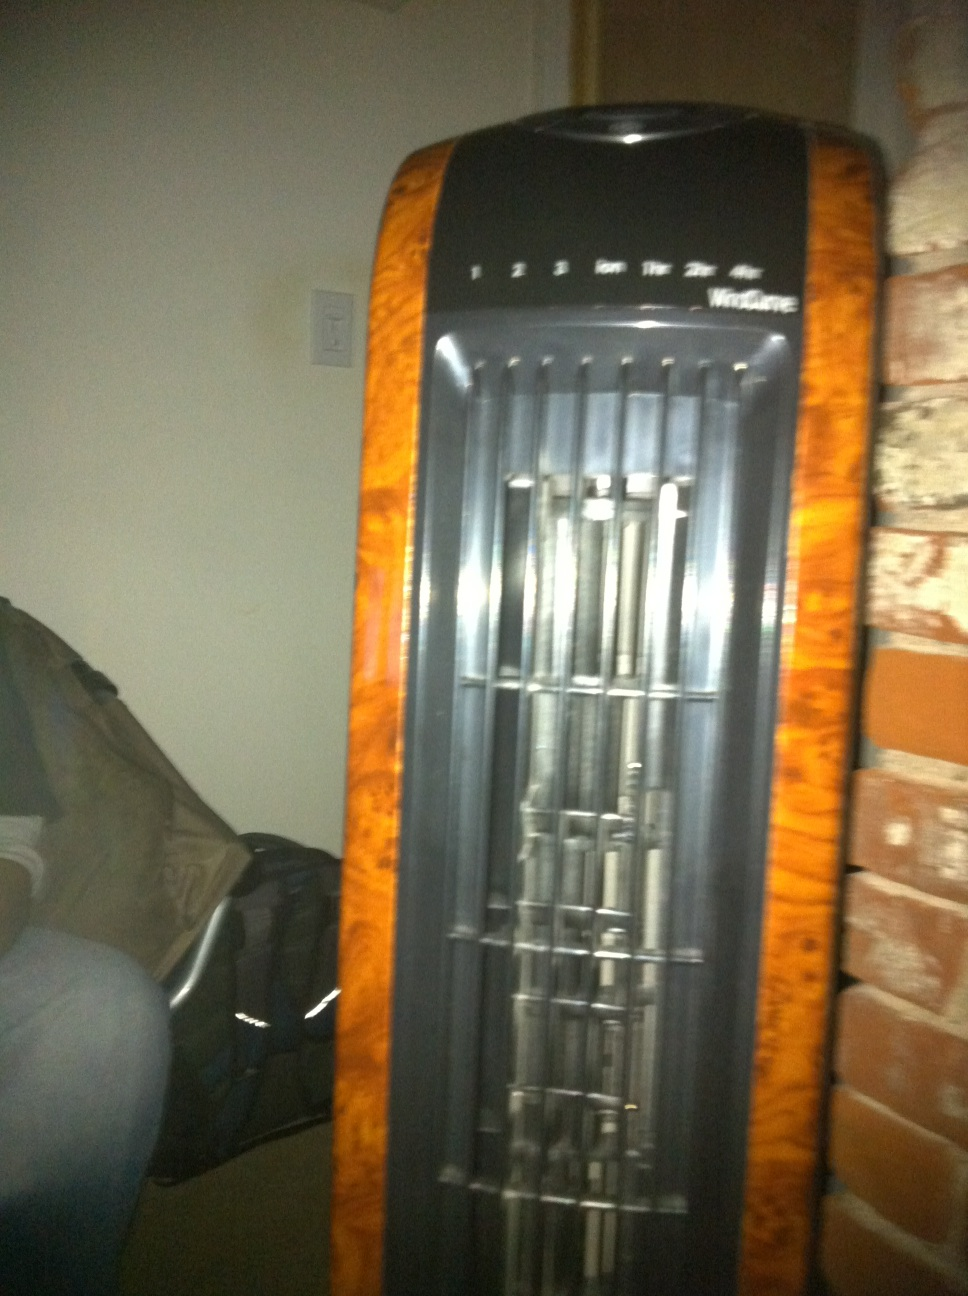What are the pros and cons of using this type of fan? Pros:
1. Space-efficient design, ideal for small areas.
2. Multiple speed settings for customizable airflow.
3. Quiet operation, suitable for use during sleep or work.
4. Modern and sleek appearance that can blend well with home decor.

Cons:
1. May not be as powerful as larger fans or air conditioners.
2. Requires regular cleaning to maintain efficiency and prevent dust buildup.
3. Limited to indoor use, not suitable for outdoor cooling.
4. Can be less effective in extremely hot environments without additional cooling systems. 